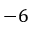Convert formula to latex. <formula><loc_0><loc_0><loc_500><loc_500>- 6</formula> 